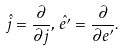Convert formula to latex. <formula><loc_0><loc_0><loc_500><loc_500>\hat { j } = \frac { \partial } { \partial j } , \, \hat { e ^ { \prime } } = \frac { \partial } { \partial e ^ { \prime } } .</formula> 